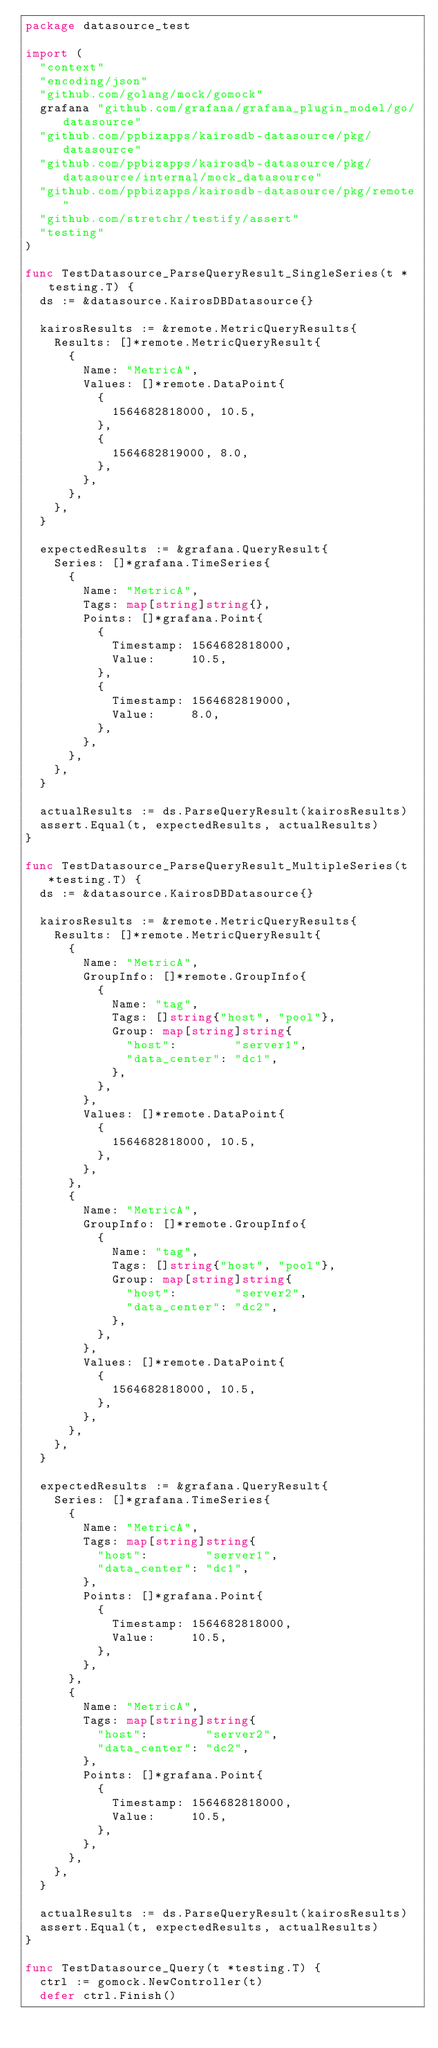<code> <loc_0><loc_0><loc_500><loc_500><_Go_>package datasource_test

import (
	"context"
	"encoding/json"
	"github.com/golang/mock/gomock"
	grafana "github.com/grafana/grafana_plugin_model/go/datasource"
	"github.com/ppbizapps/kairosdb-datasource/pkg/datasource"
	"github.com/ppbizapps/kairosdb-datasource/pkg/datasource/internal/mock_datasource"
	"github.com/ppbizapps/kairosdb-datasource/pkg/remote"
	"github.com/stretchr/testify/assert"
	"testing"
)

func TestDatasource_ParseQueryResult_SingleSeries(t *testing.T) {
	ds := &datasource.KairosDBDatasource{}

	kairosResults := &remote.MetricQueryResults{
		Results: []*remote.MetricQueryResult{
			{
				Name: "MetricA",
				Values: []*remote.DataPoint{
					{
						1564682818000, 10.5,
					},
					{
						1564682819000, 8.0,
					},
				},
			},
		},
	}

	expectedResults := &grafana.QueryResult{
		Series: []*grafana.TimeSeries{
			{
				Name: "MetricA",
				Tags: map[string]string{},
				Points: []*grafana.Point{
					{
						Timestamp: 1564682818000,
						Value:     10.5,
					},
					{
						Timestamp: 1564682819000,
						Value:     8.0,
					},
				},
			},
		},
	}

	actualResults := ds.ParseQueryResult(kairosResults)
	assert.Equal(t, expectedResults, actualResults)
}

func TestDatasource_ParseQueryResult_MultipleSeries(t *testing.T) {
	ds := &datasource.KairosDBDatasource{}

	kairosResults := &remote.MetricQueryResults{
		Results: []*remote.MetricQueryResult{
			{
				Name: "MetricA",
				GroupInfo: []*remote.GroupInfo{
					{
						Name: "tag",
						Tags: []string{"host", "pool"},
						Group: map[string]string{
							"host":        "server1",
							"data_center": "dc1",
						},
					},
				},
				Values: []*remote.DataPoint{
					{
						1564682818000, 10.5,
					},
				},
			},
			{
				Name: "MetricA",
				GroupInfo: []*remote.GroupInfo{
					{
						Name: "tag",
						Tags: []string{"host", "pool"},
						Group: map[string]string{
							"host":        "server2",
							"data_center": "dc2",
						},
					},
				},
				Values: []*remote.DataPoint{
					{
						1564682818000, 10.5,
					},
				},
			},
		},
	}

	expectedResults := &grafana.QueryResult{
		Series: []*grafana.TimeSeries{
			{
				Name: "MetricA",
				Tags: map[string]string{
					"host":        "server1",
					"data_center": "dc1",
				},
				Points: []*grafana.Point{
					{
						Timestamp: 1564682818000,
						Value:     10.5,
					},
				},
			},
			{
				Name: "MetricA",
				Tags: map[string]string{
					"host":        "server2",
					"data_center": "dc2",
				},
				Points: []*grafana.Point{
					{
						Timestamp: 1564682818000,
						Value:     10.5,
					},
				},
			},
		},
	}

	actualResults := ds.ParseQueryResult(kairosResults)
	assert.Equal(t, expectedResults, actualResults)
}

func TestDatasource_Query(t *testing.T) {
	ctrl := gomock.NewController(t)
	defer ctrl.Finish()
</code> 